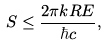<formula> <loc_0><loc_0><loc_500><loc_500>S \leq { \frac { 2 \pi k R E } { \hbar { c } } } ,</formula> 